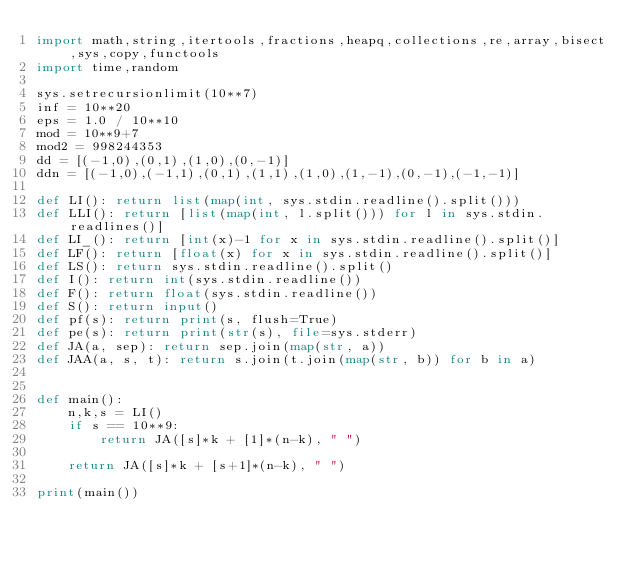Convert code to text. <code><loc_0><loc_0><loc_500><loc_500><_Python_>import math,string,itertools,fractions,heapq,collections,re,array,bisect,sys,copy,functools
import time,random

sys.setrecursionlimit(10**7)
inf = 10**20
eps = 1.0 / 10**10
mod = 10**9+7
mod2 = 998244353
dd = [(-1,0),(0,1),(1,0),(0,-1)]
ddn = [(-1,0),(-1,1),(0,1),(1,1),(1,0),(1,-1),(0,-1),(-1,-1)]

def LI(): return list(map(int, sys.stdin.readline().split()))
def LLI(): return [list(map(int, l.split())) for l in sys.stdin.readlines()]
def LI_(): return [int(x)-1 for x in sys.stdin.readline().split()]
def LF(): return [float(x) for x in sys.stdin.readline().split()]
def LS(): return sys.stdin.readline().split()
def I(): return int(sys.stdin.readline())
def F(): return float(sys.stdin.readline())
def S(): return input()
def pf(s): return print(s, flush=True)
def pe(s): return print(str(s), file=sys.stderr)
def JA(a, sep): return sep.join(map(str, a))
def JAA(a, s, t): return s.join(t.join(map(str, b)) for b in a)


def main():
    n,k,s = LI()
    if s == 10**9:
        return JA([s]*k + [1]*(n-k), " ")

    return JA([s]*k + [s+1]*(n-k), " ")

print(main())



</code> 